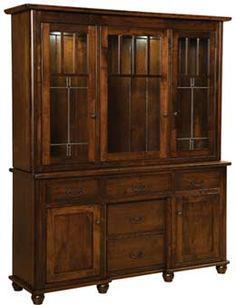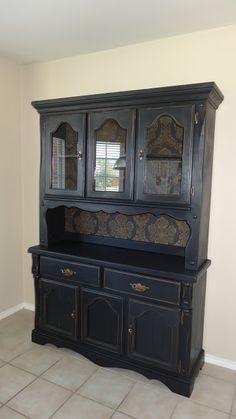The first image is the image on the left, the second image is the image on the right. Analyze the images presented: Is the assertion "At least one of the cabinets is dark and has no glass-front doors, and none of the cabinets are distinctly taller than they are wide." valid? Answer yes or no. No. 